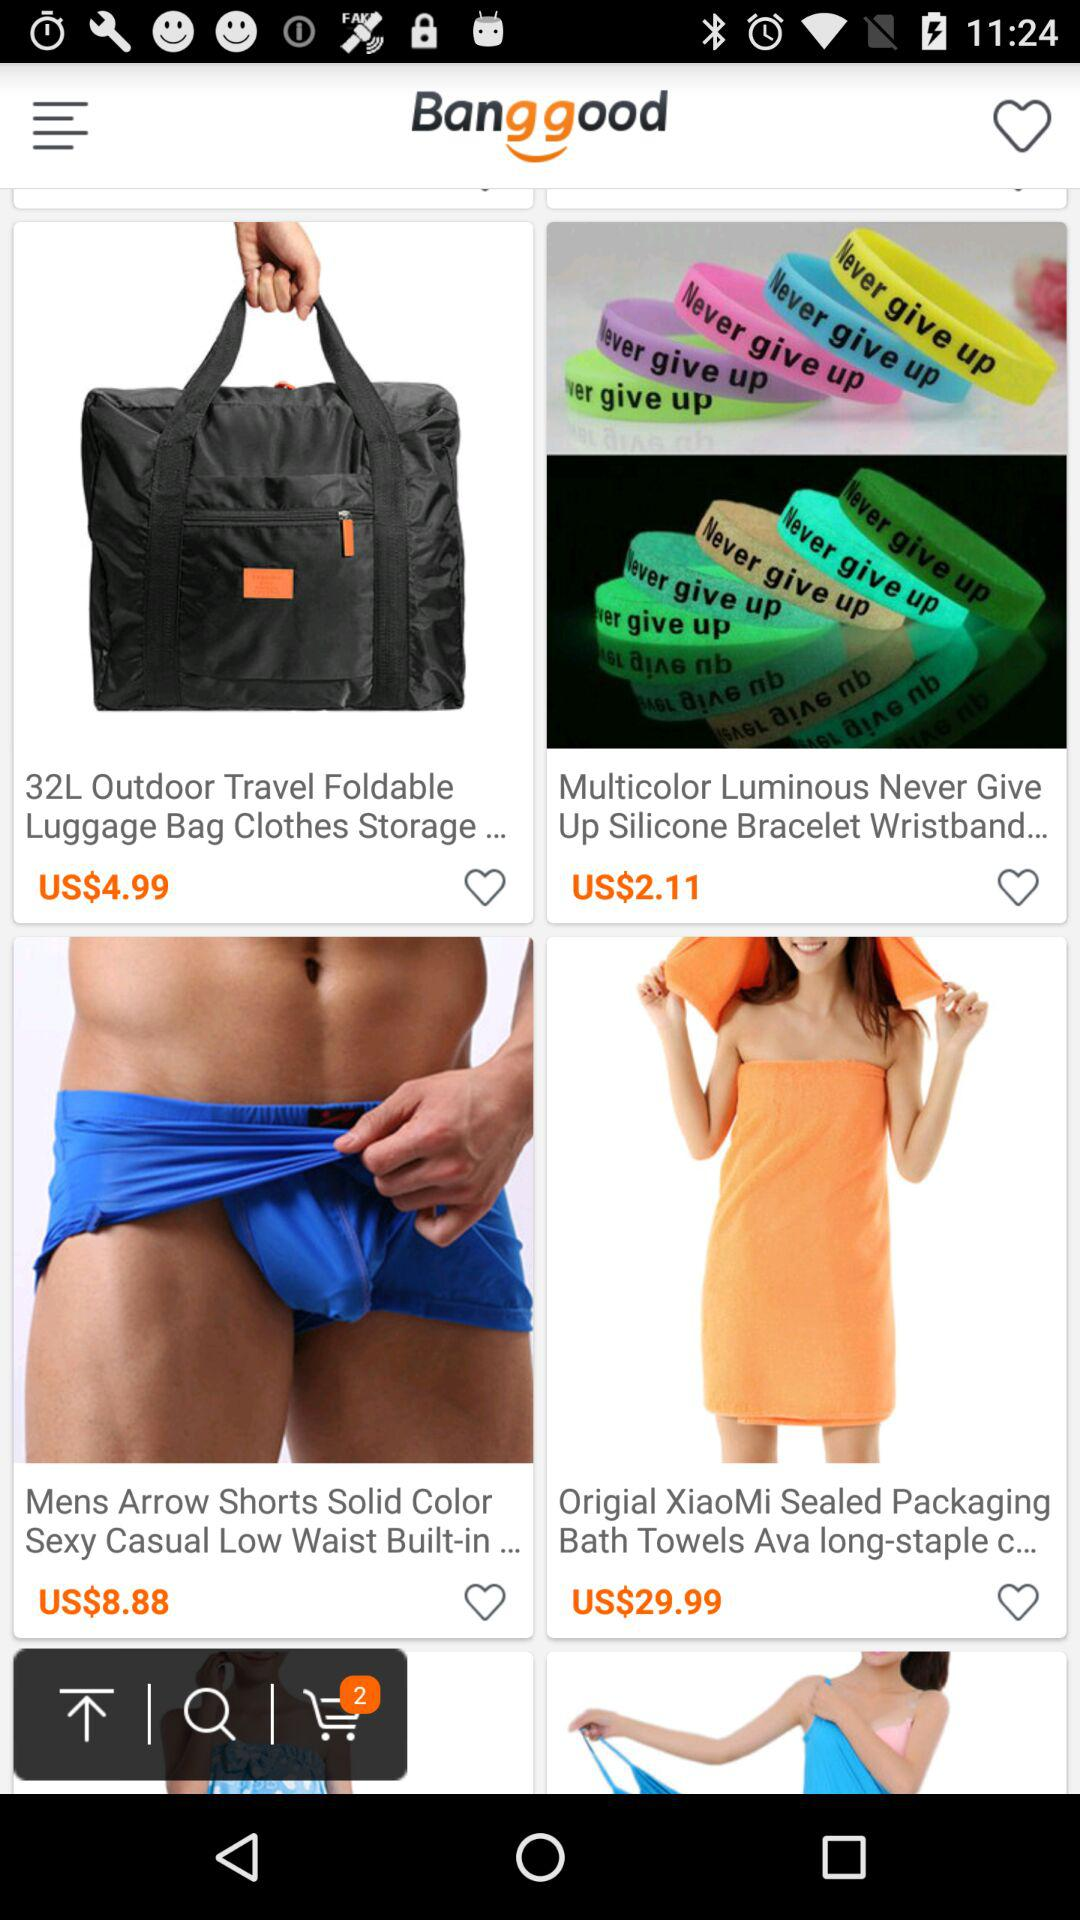How many items are in the shopping cart?
Answer the question using a single word or phrase. 2 